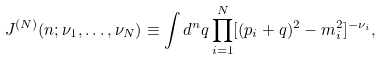<formula> <loc_0><loc_0><loc_500><loc_500>J ^ { ( N ) } ( n ; \nu _ { 1 } , \dots , \nu _ { N } ) \equiv \int d ^ { n } q \prod _ { i = 1 } ^ { N } [ ( p _ { i } + q ) ^ { 2 } - m _ { i } ^ { 2 } ] ^ { - \nu _ { i } } ,</formula> 